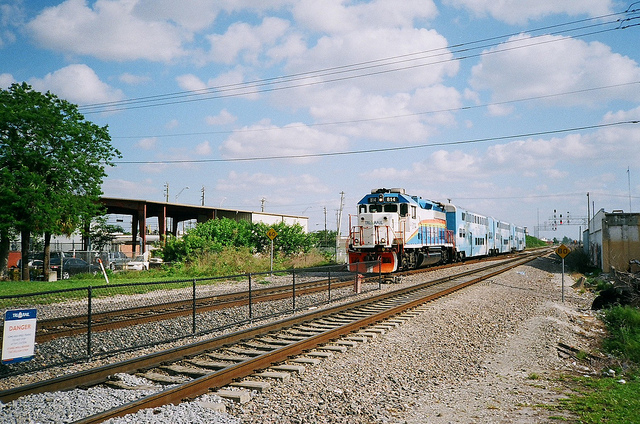<image>What vegetation is behind the train? I don't know what kind of vegetation is behind the train. It could be trees or bushes. Why are there rocks in between the tracks? It is unknown why there are rocks in between the tracks. They may provide stability or serve as a design element. What vegetation is behind the train? There are trees and bushes behind the train. Why are there rocks in between the tracks? I don't know why there are rocks in between the tracks. It can be for protection, stability, to fill in space, or for decoration. 